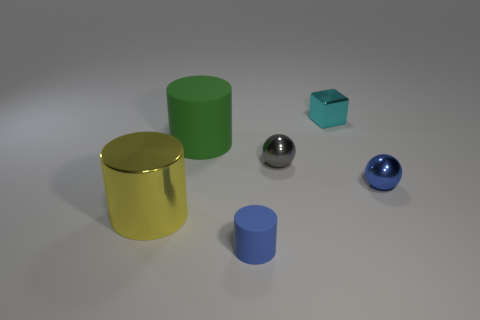Do the matte cylinder in front of the big matte object and the rubber cylinder behind the tiny gray sphere have the same size?
Give a very brief answer. No. Are there any other metal things of the same shape as the big yellow object?
Offer a terse response. No. Are there fewer tiny cyan metal objects to the right of the small cube than large green rubber cylinders?
Give a very brief answer. Yes. Does the gray object have the same shape as the cyan metallic thing?
Ensure brevity in your answer.  No. There is a matte object that is behind the big yellow cylinder; what is its size?
Your answer should be compact. Large. What is the size of the cyan thing that is made of the same material as the small gray object?
Your answer should be very brief. Small. Are there fewer tiny matte objects than tiny brown shiny cylinders?
Your answer should be compact. No. There is a gray ball that is the same size as the cyan metal thing; what is it made of?
Your answer should be compact. Metal. Is the number of tiny gray objects greater than the number of purple balls?
Your answer should be very brief. Yes. What number of other things are the same color as the cube?
Provide a succinct answer. 0. 